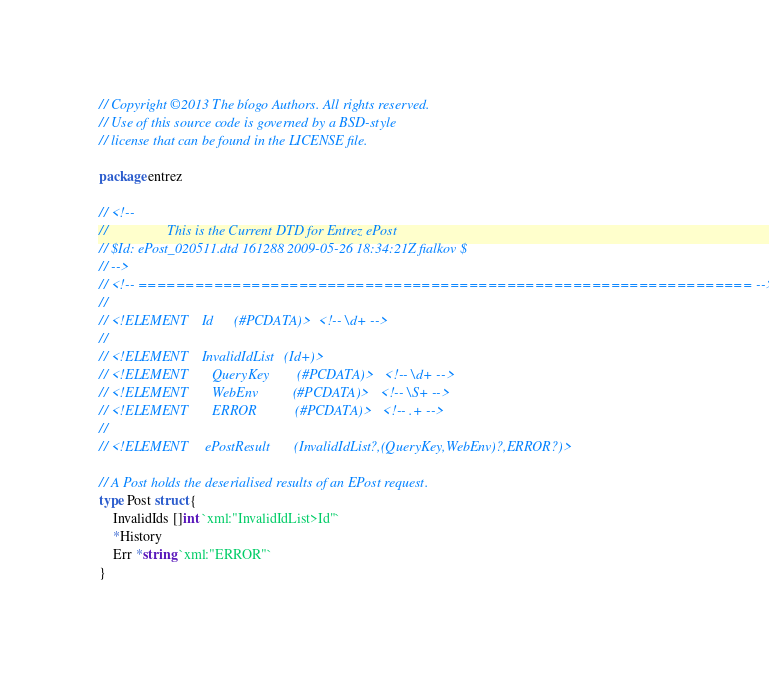<code> <loc_0><loc_0><loc_500><loc_500><_Go_>// Copyright ©2013 The bíogo Authors. All rights reserved.
// Use of this source code is governed by a BSD-style
// license that can be found in the LICENSE file.

package entrez

// <!--
//                 This is the Current DTD for Entrez ePost
// $Id: ePost_020511.dtd 161288 2009-05-26 18:34:21Z fialkov $
// -->
// <!-- ================================================================= -->
//
// <!ELEMENT	Id		(#PCDATA)>	<!-- \d+ -->
//
// <!ELEMENT	InvalidIdList	(Id+)>
// <!ELEMENT       QueryKey        (#PCDATA)>	<!-- \d+ -->
// <!ELEMENT       WebEnv          (#PCDATA)>	<!-- \S+ -->
// <!ELEMENT       ERROR           (#PCDATA)>	<!-- .+ -->
//
// <!ELEMENT     ePostResult       (InvalidIdList?,(QueryKey,WebEnv)?,ERROR?)>

// A Post holds the deserialised results of an EPost request.
type Post struct {
	InvalidIds []int `xml:"InvalidIdList>Id"`
	*History
	Err *string `xml:"ERROR"`
}
</code> 